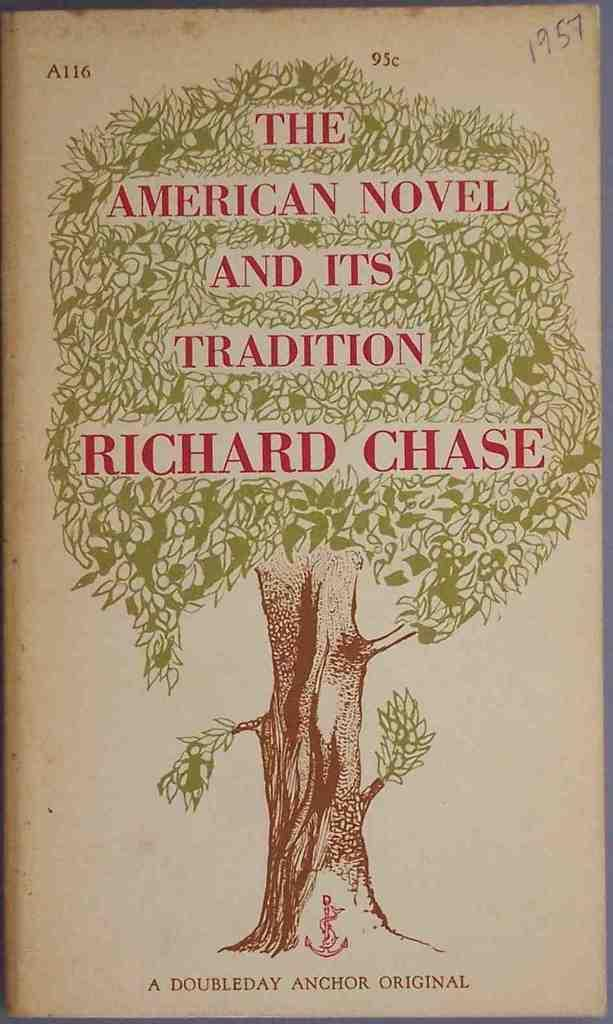<image>
Relay a brief, clear account of the picture shown. A book with a tree on it called American Novel and its tradition by Richard Chase. 